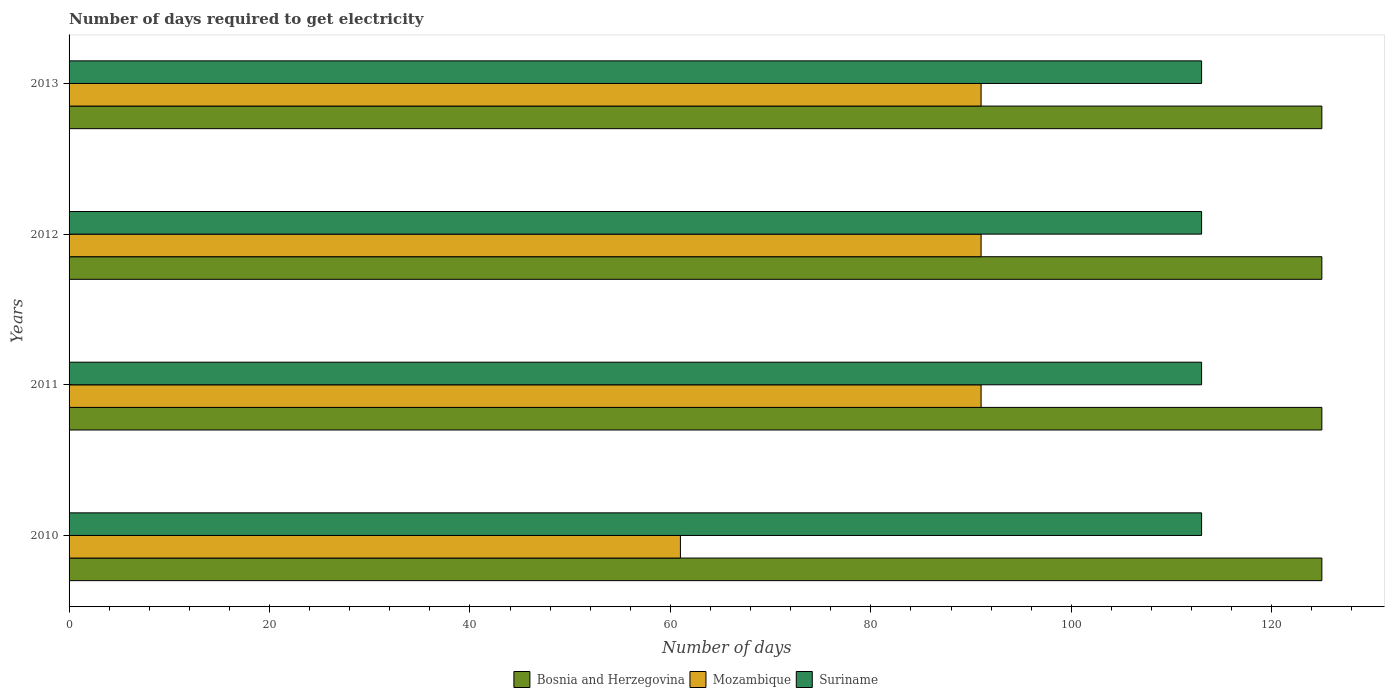How many different coloured bars are there?
Keep it short and to the point. 3. How many bars are there on the 1st tick from the top?
Your answer should be compact. 3. What is the label of the 2nd group of bars from the top?
Offer a very short reply. 2012. In how many cases, is the number of bars for a given year not equal to the number of legend labels?
Your answer should be compact. 0. What is the number of days required to get electricity in in Mozambique in 2012?
Provide a succinct answer. 91. Across all years, what is the maximum number of days required to get electricity in in Suriname?
Provide a succinct answer. 113. Across all years, what is the minimum number of days required to get electricity in in Suriname?
Offer a very short reply. 113. In which year was the number of days required to get electricity in in Bosnia and Herzegovina minimum?
Offer a very short reply. 2010. What is the total number of days required to get electricity in in Suriname in the graph?
Provide a succinct answer. 452. What is the difference between the number of days required to get electricity in in Bosnia and Herzegovina in 2010 and that in 2011?
Offer a terse response. 0. What is the difference between the number of days required to get electricity in in Bosnia and Herzegovina in 2010 and the number of days required to get electricity in in Suriname in 2013?
Offer a terse response. 12. What is the average number of days required to get electricity in in Mozambique per year?
Your answer should be compact. 83.5. In the year 2012, what is the difference between the number of days required to get electricity in in Bosnia and Herzegovina and number of days required to get electricity in in Mozambique?
Make the answer very short. 34. Is the number of days required to get electricity in in Mozambique in 2010 less than that in 2011?
Give a very brief answer. Yes. Is the difference between the number of days required to get electricity in in Bosnia and Herzegovina in 2010 and 2013 greater than the difference between the number of days required to get electricity in in Mozambique in 2010 and 2013?
Offer a terse response. Yes. What is the difference between the highest and the lowest number of days required to get electricity in in Mozambique?
Your answer should be compact. 30. In how many years, is the number of days required to get electricity in in Mozambique greater than the average number of days required to get electricity in in Mozambique taken over all years?
Your response must be concise. 3. What does the 2nd bar from the top in 2011 represents?
Your answer should be very brief. Mozambique. What does the 1st bar from the bottom in 2010 represents?
Provide a succinct answer. Bosnia and Herzegovina. Are the values on the major ticks of X-axis written in scientific E-notation?
Give a very brief answer. No. Does the graph contain any zero values?
Provide a short and direct response. No. Does the graph contain grids?
Your response must be concise. No. Where does the legend appear in the graph?
Provide a short and direct response. Bottom center. How many legend labels are there?
Your response must be concise. 3. What is the title of the graph?
Make the answer very short. Number of days required to get electricity. Does "Swaziland" appear as one of the legend labels in the graph?
Provide a short and direct response. No. What is the label or title of the X-axis?
Provide a short and direct response. Number of days. What is the Number of days of Bosnia and Herzegovina in 2010?
Your answer should be very brief. 125. What is the Number of days of Mozambique in 2010?
Make the answer very short. 61. What is the Number of days of Suriname in 2010?
Your answer should be very brief. 113. What is the Number of days in Bosnia and Herzegovina in 2011?
Ensure brevity in your answer.  125. What is the Number of days in Mozambique in 2011?
Provide a succinct answer. 91. What is the Number of days in Suriname in 2011?
Provide a succinct answer. 113. What is the Number of days of Bosnia and Herzegovina in 2012?
Keep it short and to the point. 125. What is the Number of days in Mozambique in 2012?
Offer a terse response. 91. What is the Number of days in Suriname in 2012?
Keep it short and to the point. 113. What is the Number of days of Bosnia and Herzegovina in 2013?
Provide a succinct answer. 125. What is the Number of days in Mozambique in 2013?
Your answer should be very brief. 91. What is the Number of days of Suriname in 2013?
Your response must be concise. 113. Across all years, what is the maximum Number of days of Bosnia and Herzegovina?
Provide a succinct answer. 125. Across all years, what is the maximum Number of days of Mozambique?
Provide a short and direct response. 91. Across all years, what is the maximum Number of days of Suriname?
Offer a terse response. 113. Across all years, what is the minimum Number of days in Bosnia and Herzegovina?
Provide a succinct answer. 125. Across all years, what is the minimum Number of days in Mozambique?
Your response must be concise. 61. Across all years, what is the minimum Number of days of Suriname?
Offer a very short reply. 113. What is the total Number of days of Bosnia and Herzegovina in the graph?
Ensure brevity in your answer.  500. What is the total Number of days of Mozambique in the graph?
Provide a short and direct response. 334. What is the total Number of days in Suriname in the graph?
Your answer should be compact. 452. What is the difference between the Number of days in Bosnia and Herzegovina in 2010 and that in 2011?
Ensure brevity in your answer.  0. What is the difference between the Number of days in Mozambique in 2010 and that in 2011?
Your response must be concise. -30. What is the difference between the Number of days of Suriname in 2010 and that in 2011?
Make the answer very short. 0. What is the difference between the Number of days in Mozambique in 2010 and that in 2012?
Provide a succinct answer. -30. What is the difference between the Number of days of Bosnia and Herzegovina in 2010 and that in 2013?
Offer a terse response. 0. What is the difference between the Number of days of Mozambique in 2010 and that in 2013?
Provide a succinct answer. -30. What is the difference between the Number of days in Suriname in 2010 and that in 2013?
Your answer should be very brief. 0. What is the difference between the Number of days of Bosnia and Herzegovina in 2011 and that in 2013?
Offer a terse response. 0. What is the difference between the Number of days in Suriname in 2011 and that in 2013?
Your answer should be very brief. 0. What is the difference between the Number of days of Suriname in 2012 and that in 2013?
Provide a short and direct response. 0. What is the difference between the Number of days in Bosnia and Herzegovina in 2010 and the Number of days in Mozambique in 2011?
Your answer should be compact. 34. What is the difference between the Number of days of Bosnia and Herzegovina in 2010 and the Number of days of Suriname in 2011?
Keep it short and to the point. 12. What is the difference between the Number of days of Mozambique in 2010 and the Number of days of Suriname in 2011?
Your answer should be compact. -52. What is the difference between the Number of days in Bosnia and Herzegovina in 2010 and the Number of days in Suriname in 2012?
Give a very brief answer. 12. What is the difference between the Number of days of Mozambique in 2010 and the Number of days of Suriname in 2012?
Provide a short and direct response. -52. What is the difference between the Number of days of Bosnia and Herzegovina in 2010 and the Number of days of Mozambique in 2013?
Offer a terse response. 34. What is the difference between the Number of days of Bosnia and Herzegovina in 2010 and the Number of days of Suriname in 2013?
Make the answer very short. 12. What is the difference between the Number of days in Mozambique in 2010 and the Number of days in Suriname in 2013?
Offer a very short reply. -52. What is the difference between the Number of days in Bosnia and Herzegovina in 2011 and the Number of days in Suriname in 2012?
Ensure brevity in your answer.  12. What is the difference between the Number of days of Mozambique in 2011 and the Number of days of Suriname in 2012?
Your answer should be very brief. -22. What is the difference between the Number of days of Mozambique in 2011 and the Number of days of Suriname in 2013?
Your response must be concise. -22. What is the difference between the Number of days in Bosnia and Herzegovina in 2012 and the Number of days in Mozambique in 2013?
Your response must be concise. 34. What is the difference between the Number of days of Bosnia and Herzegovina in 2012 and the Number of days of Suriname in 2013?
Offer a terse response. 12. What is the difference between the Number of days of Mozambique in 2012 and the Number of days of Suriname in 2013?
Your answer should be compact. -22. What is the average Number of days in Bosnia and Herzegovina per year?
Your response must be concise. 125. What is the average Number of days of Mozambique per year?
Your response must be concise. 83.5. What is the average Number of days in Suriname per year?
Ensure brevity in your answer.  113. In the year 2010, what is the difference between the Number of days in Bosnia and Herzegovina and Number of days in Mozambique?
Your answer should be compact. 64. In the year 2010, what is the difference between the Number of days of Bosnia and Herzegovina and Number of days of Suriname?
Ensure brevity in your answer.  12. In the year 2010, what is the difference between the Number of days of Mozambique and Number of days of Suriname?
Your response must be concise. -52. In the year 2011, what is the difference between the Number of days of Bosnia and Herzegovina and Number of days of Mozambique?
Offer a terse response. 34. In the year 2011, what is the difference between the Number of days of Mozambique and Number of days of Suriname?
Offer a terse response. -22. In the year 2012, what is the difference between the Number of days in Bosnia and Herzegovina and Number of days in Mozambique?
Give a very brief answer. 34. In the year 2012, what is the difference between the Number of days of Mozambique and Number of days of Suriname?
Your answer should be compact. -22. In the year 2013, what is the difference between the Number of days of Bosnia and Herzegovina and Number of days of Mozambique?
Give a very brief answer. 34. What is the ratio of the Number of days in Bosnia and Herzegovina in 2010 to that in 2011?
Make the answer very short. 1. What is the ratio of the Number of days of Mozambique in 2010 to that in 2011?
Your answer should be very brief. 0.67. What is the ratio of the Number of days in Suriname in 2010 to that in 2011?
Your answer should be very brief. 1. What is the ratio of the Number of days in Bosnia and Herzegovina in 2010 to that in 2012?
Offer a very short reply. 1. What is the ratio of the Number of days in Mozambique in 2010 to that in 2012?
Ensure brevity in your answer.  0.67. What is the ratio of the Number of days of Mozambique in 2010 to that in 2013?
Keep it short and to the point. 0.67. What is the ratio of the Number of days in Suriname in 2010 to that in 2013?
Your answer should be compact. 1. What is the ratio of the Number of days in Suriname in 2011 to that in 2012?
Keep it short and to the point. 1. What is the ratio of the Number of days in Bosnia and Herzegovina in 2011 to that in 2013?
Your answer should be very brief. 1. What is the ratio of the Number of days in Suriname in 2011 to that in 2013?
Provide a short and direct response. 1. What is the ratio of the Number of days in Bosnia and Herzegovina in 2012 to that in 2013?
Provide a succinct answer. 1. What is the ratio of the Number of days of Suriname in 2012 to that in 2013?
Ensure brevity in your answer.  1. What is the difference between the highest and the second highest Number of days in Bosnia and Herzegovina?
Your answer should be very brief. 0. What is the difference between the highest and the second highest Number of days of Mozambique?
Your answer should be compact. 0. What is the difference between the highest and the second highest Number of days in Suriname?
Provide a short and direct response. 0. What is the difference between the highest and the lowest Number of days of Mozambique?
Your response must be concise. 30. 